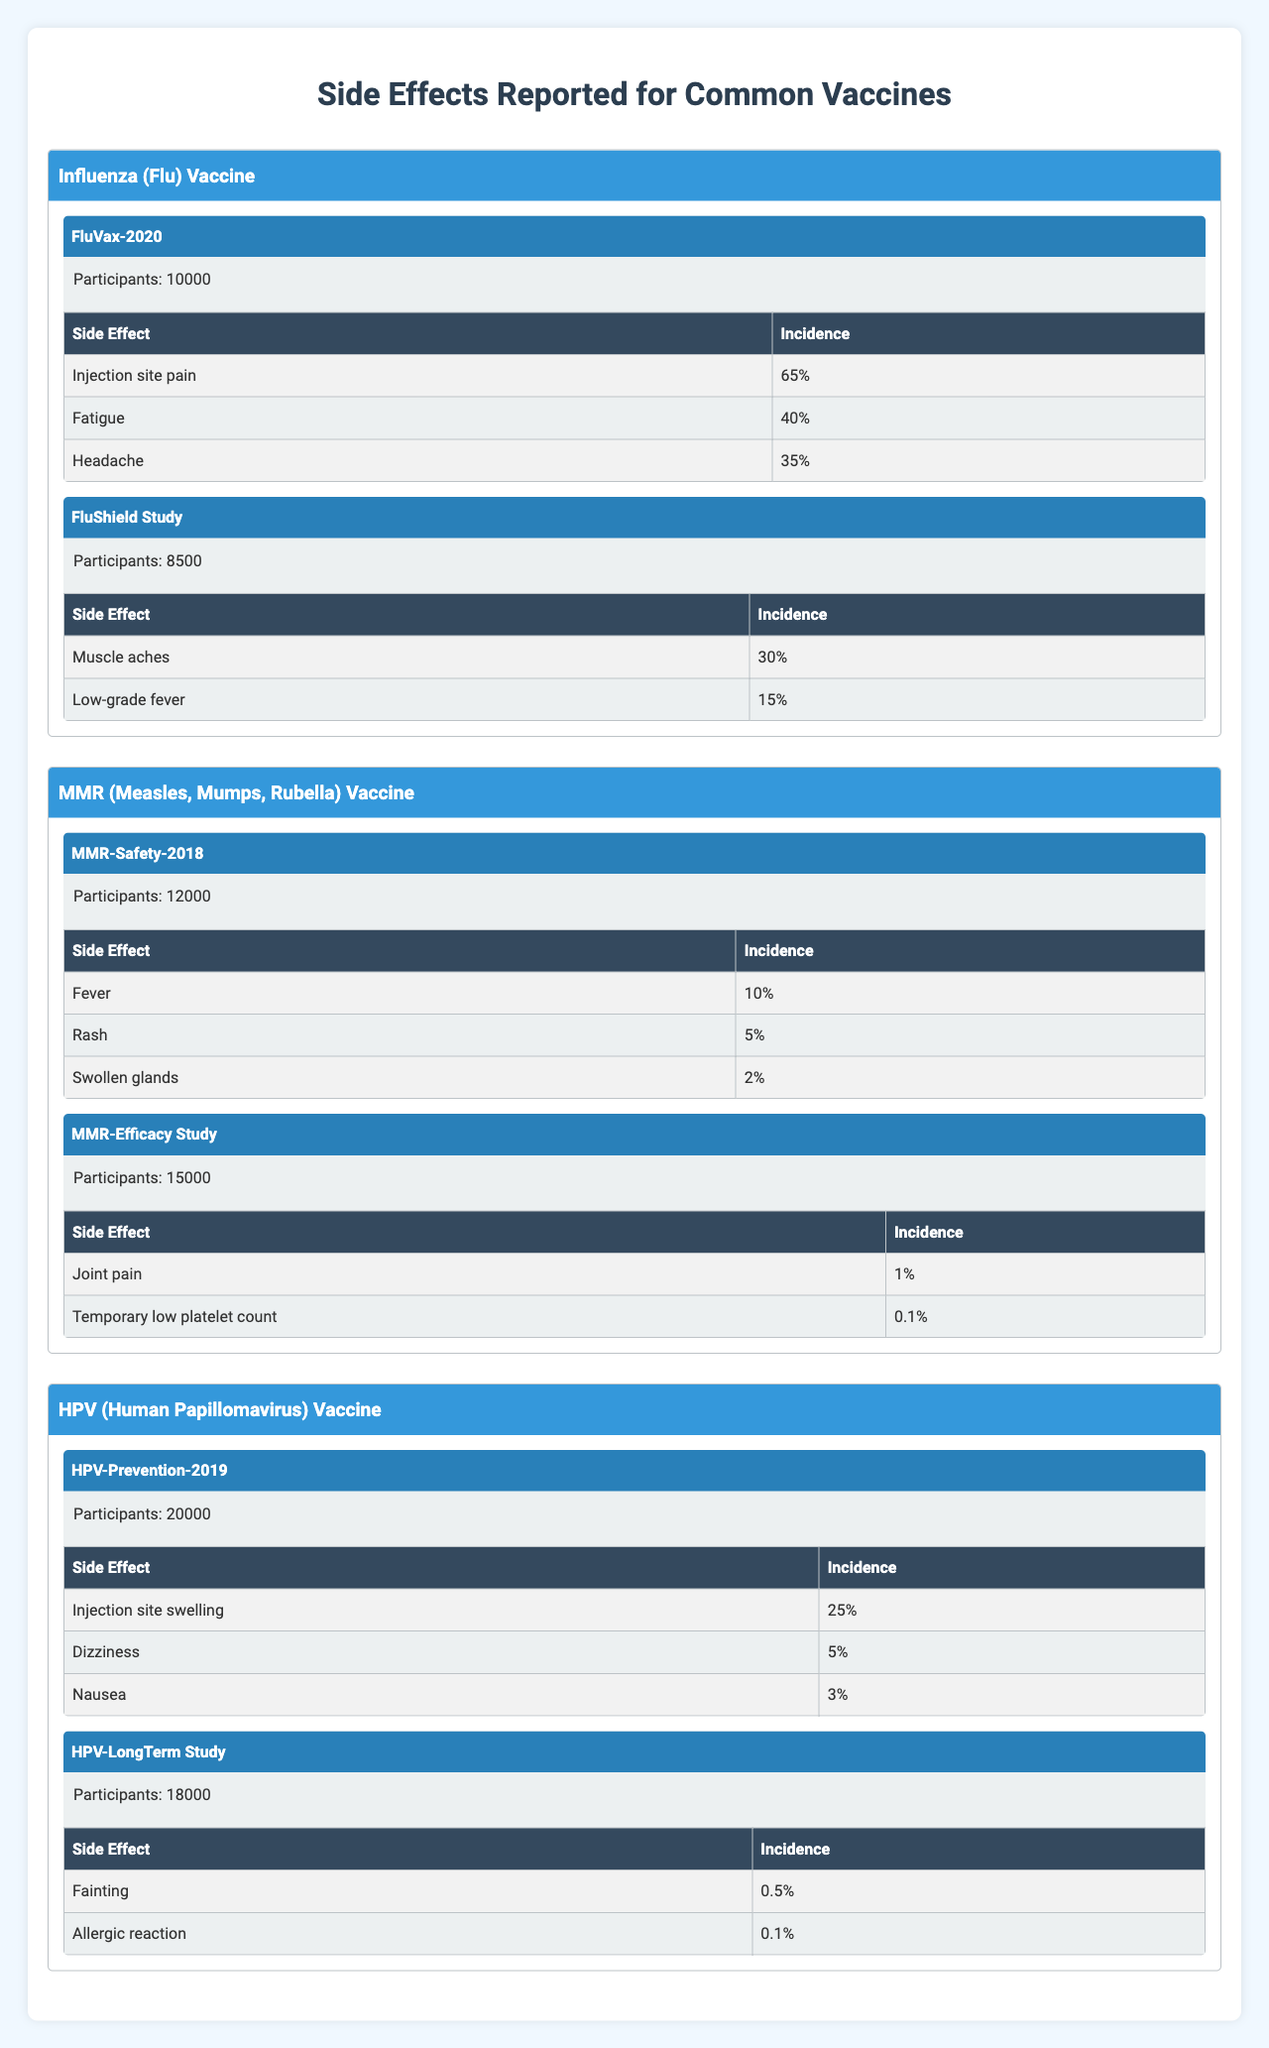What is the side effect with the highest incidence for the Influenza Vaccine? The table shows that the side effect with the highest incidence for the Influenza Vaccine is "Injection site pain" at 65%.
Answer: Injection site pain What is the total number of participants in all clinical trials for the MMR Vaccine? The total number of participants is found by adding 12,000 (MMR-Safety-2018) and 15,000 (MMR-Efficacy Study), which equals 27,000.
Answer: 27,000 Does the HPV vaccine report any side effects with an incidence higher than 25%? The table lists the side effects for the HPV Vaccine, and none have an incidence higher than 25%; the highest is "Injection site swelling" at 25%.
Answer: No What is the average incidence of side effects reported in the Flu Vaccine trials? The side effects reported are 65% for injection site pain, 40% for fatigue, and 35% for headache. The average is (65 + 40 + 35) / 3 = 46.67%.
Answer: 46.67% Is there a common side effect shared between the Influenza and HPV vaccines? Reviewing the side effects, none are common; the reported side effects for both vaccines differ completely.
Answer: No What is the total incidence of side effects reported in the MMR-Efficacy Study? The side effects reported are 1% for joint pain and 0.1% for temporary low platelet count, totaling 1.1%.
Answer: 1.1% Which vaccine has the lowest reported incidence of side effects overall? The MMR Vaccine shows the lowest incidences, with the highest recorded incidence being 10% (fever) in its trials.
Answer: MMR Vaccine Count the number of distinct side effects reported across all vaccine trials. The side effects listed are unique across the trials: 7 distinct side effects (injection site pain, fatigue, headache, muscle aches, low-grade fever, fever, rash, swollen glands, joint pain, etc.), totaling 12.
Answer: 12 What is the difference in total participants between the HPV and MMR Vaccine trials? HPV trials have 20,000 + 18,000 = 38,000 participants, and MMR trials have 12,000 + 15,000 = 27,000 participants; the difference is 38,000 - 27,000 = 11,000.
Answer: 11,000 Which trial reported the side effect "Temporary low platelet count"? The side effect "Temporary low platelet count" is reported in the MMR-Efficacy Study trial.
Answer: MMR-Efficacy Study 